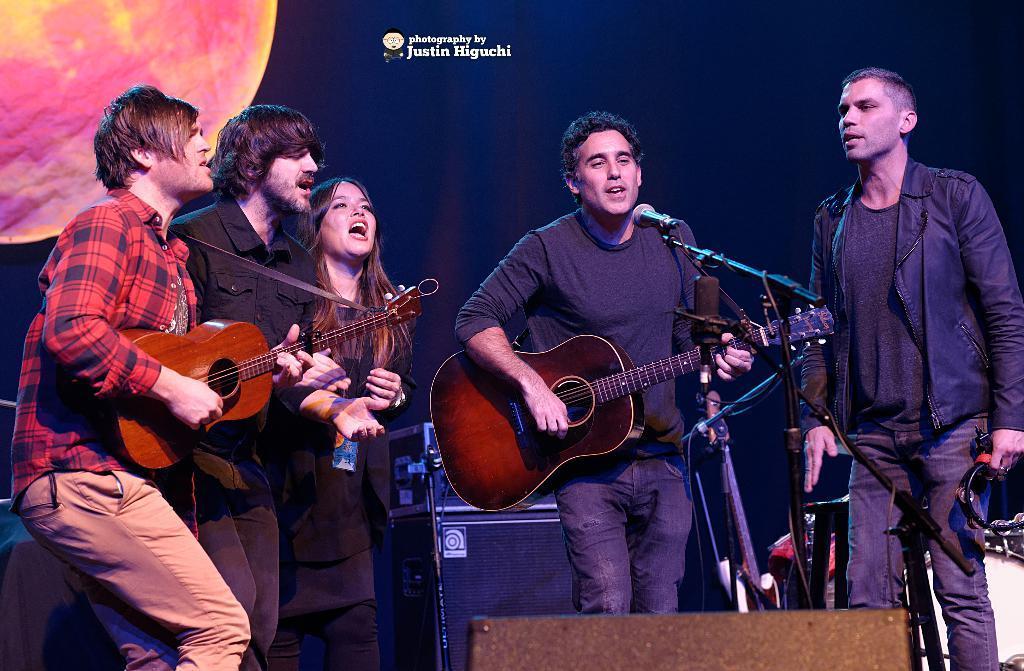Please provide a concise description of this image. In this picture there are four men and a woman who are playing musical instruments. There is a mic and there is poster at the background. 